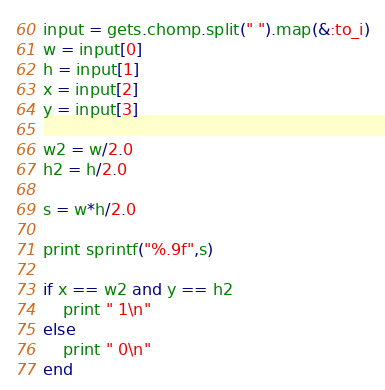Convert code to text. <code><loc_0><loc_0><loc_500><loc_500><_Ruby_>input = gets.chomp.split(" ").map(&:to_i)
w = input[0]
h = input[1]
x = input[2]
y = input[3]

w2 = w/2.0
h2 = h/2.0

s = w*h/2.0

print sprintf("%.9f",s) 

if x == w2 and y == h2 
    print " 1\n"
else
    print " 0\n"
end</code> 